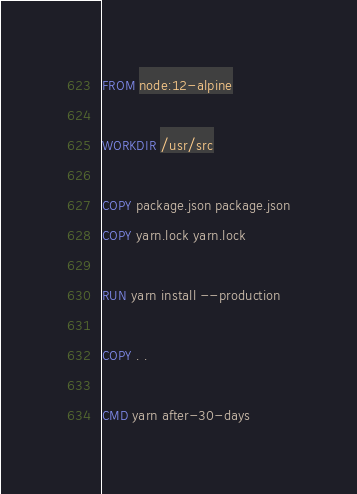<code> <loc_0><loc_0><loc_500><loc_500><_Dockerfile_>FROM node:12-alpine

WORKDIR /usr/src

COPY package.json package.json
COPY yarn.lock yarn.lock

RUN yarn install --production

COPY . .

CMD yarn after-30-days
</code> 